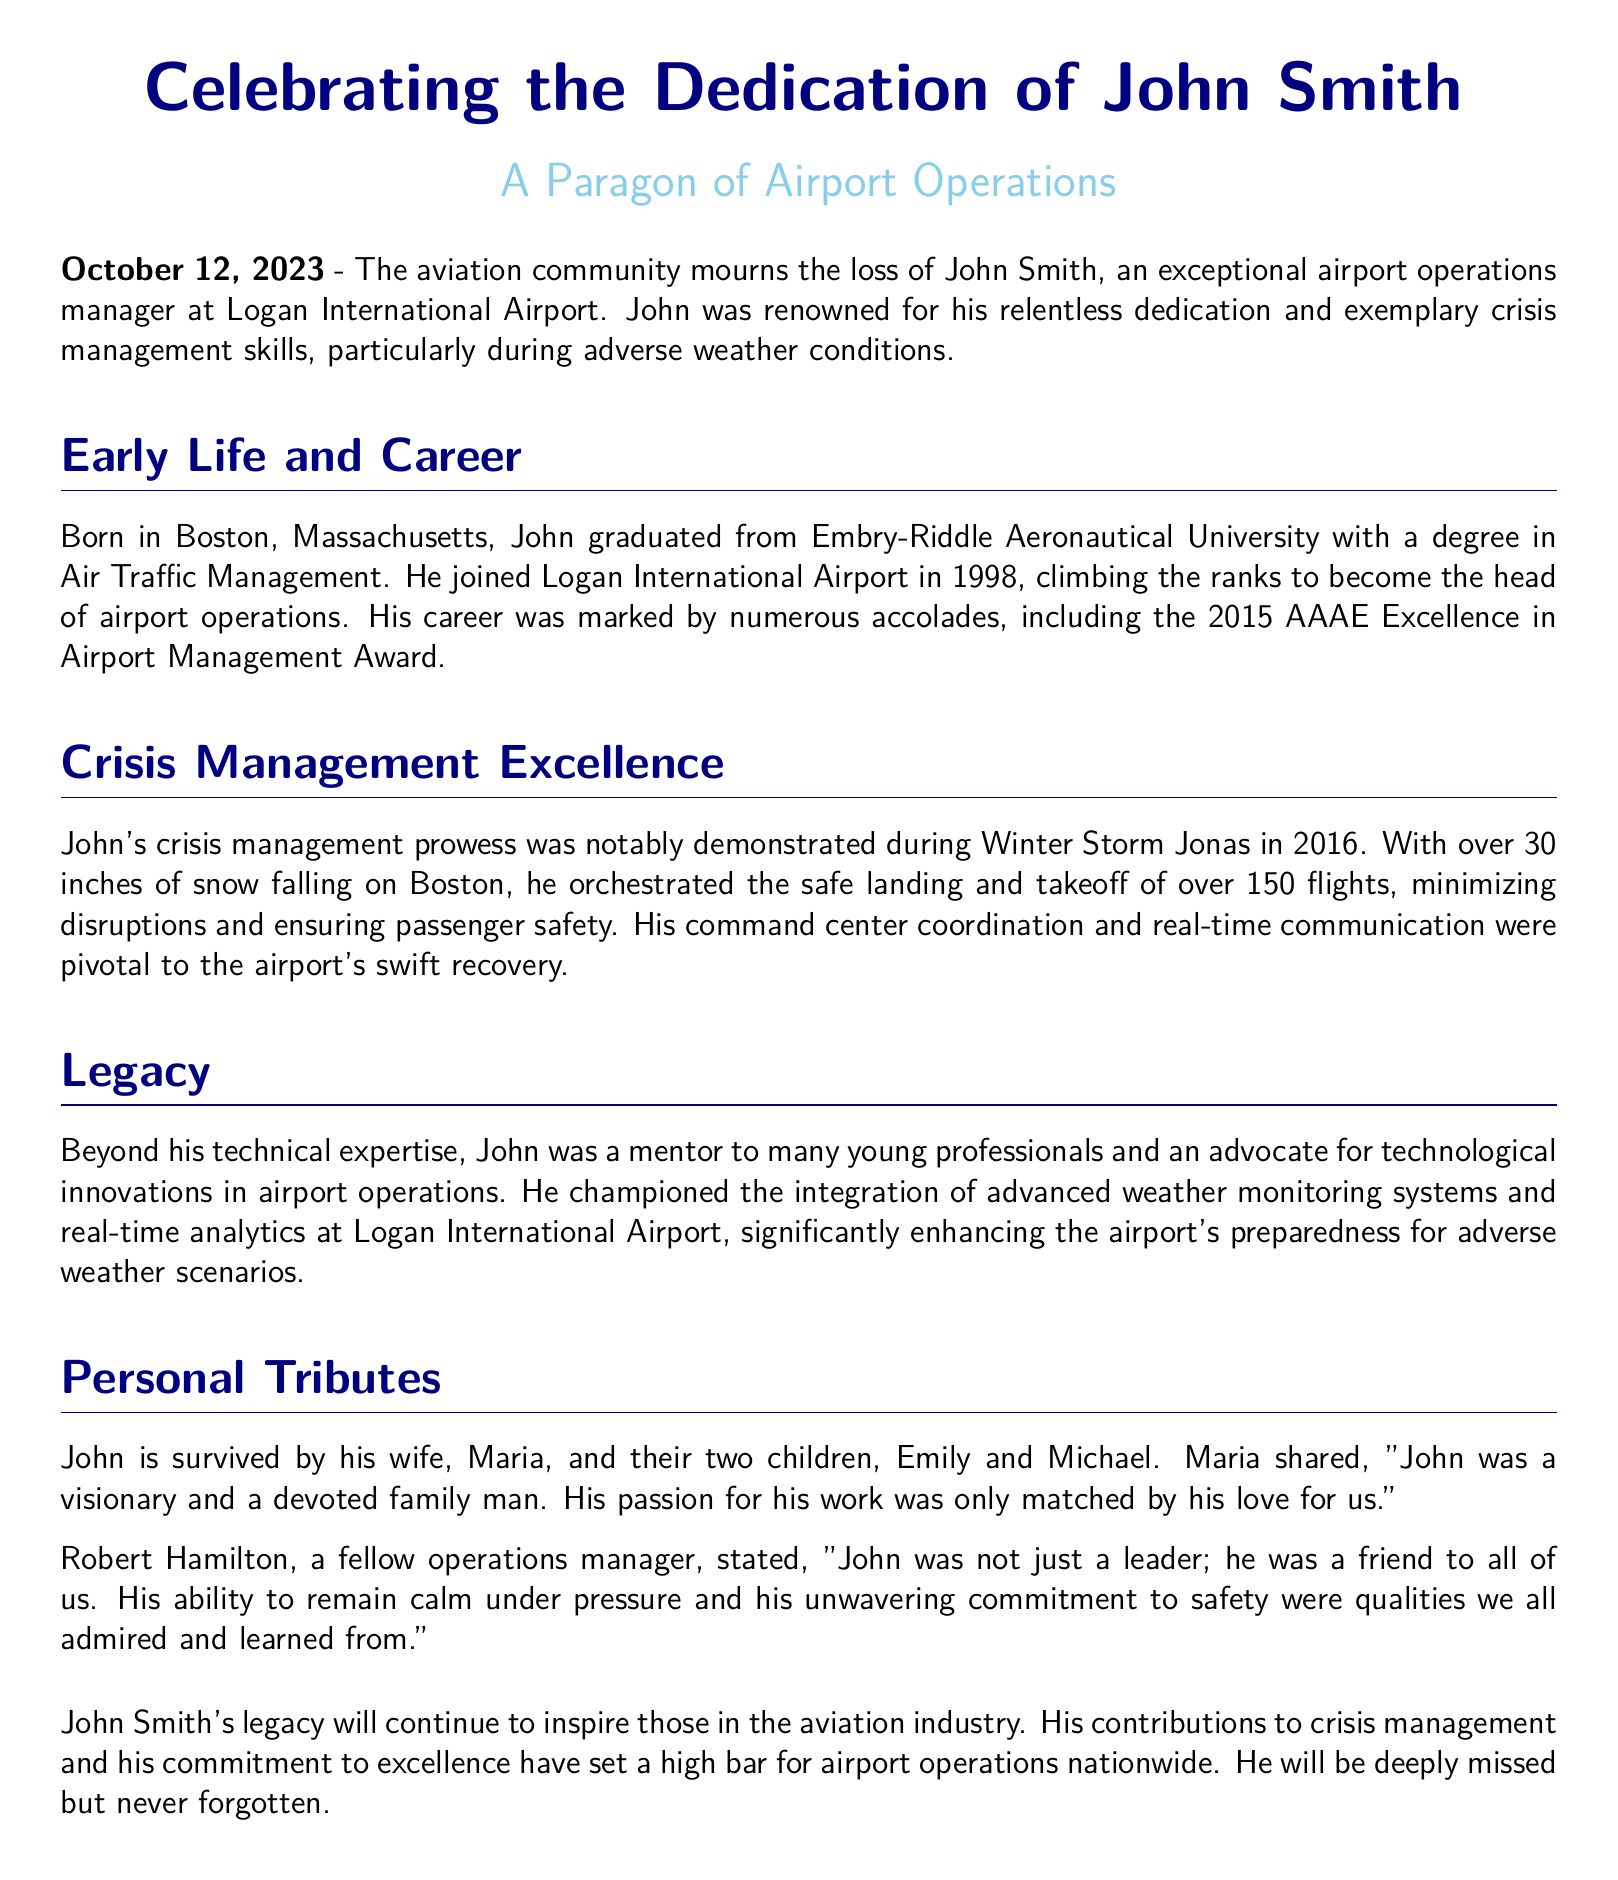What is the date of John's death? The date mentioned in the document is when the obituary was published, which is October 12, 2023.
Answer: October 12, 2023 What award did John Smith receive in 2015? The document states that John received the AAAE Excellence in Airport Management Award in 2015.
Answer: AAAE Excellence in Airport Management Award How many flights did John manage during Winter Storm Jonas? The document specifies that he orchestrated the safe landing and takeoff of over 150 flights during the storm.
Answer: over 150 flights What was John's occupation at Logan International Airport? The document identifies John Smith as an airport operations manager at Logan International Airport.
Answer: airport operations manager Who is John Smith survived by? The personal tributes mention that John is survived by his wife, Maria, and their two children, Emily and Michael.
Answer: Maria, Emily, Michael What did Robert Hamilton describe John as, besides a leader? Robert Hamilton referred to John as a friend in addition to being a leader.
Answer: friend What significant technology did John advocate for? The document highlights that John championed the integration of advanced weather monitoring systems at Logan International Airport.
Answer: advanced weather monitoring systems What city was John Smith born in? The document states that John was born in Boston, Massachusetts.
Answer: Boston 